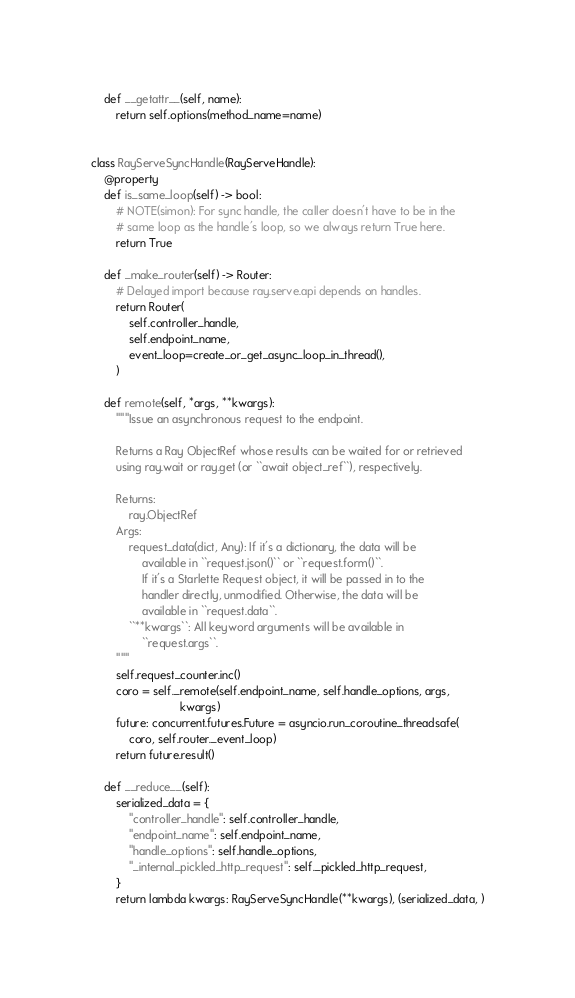<code> <loc_0><loc_0><loc_500><loc_500><_Python_>
    def __getattr__(self, name):
        return self.options(method_name=name)


class RayServeSyncHandle(RayServeHandle):
    @property
    def is_same_loop(self) -> bool:
        # NOTE(simon): For sync handle, the caller doesn't have to be in the
        # same loop as the handle's loop, so we always return True here.
        return True

    def _make_router(self) -> Router:
        # Delayed import because ray.serve.api depends on handles.
        return Router(
            self.controller_handle,
            self.endpoint_name,
            event_loop=create_or_get_async_loop_in_thread(),
        )

    def remote(self, *args, **kwargs):
        """Issue an asynchronous request to the endpoint.

        Returns a Ray ObjectRef whose results can be waited for or retrieved
        using ray.wait or ray.get (or ``await object_ref``), respectively.

        Returns:
            ray.ObjectRef
        Args:
            request_data(dict, Any): If it's a dictionary, the data will be
                available in ``request.json()`` or ``request.form()``.
                If it's a Starlette Request object, it will be passed in to the
                handler directly, unmodified. Otherwise, the data will be
                available in ``request.data``.
            ``**kwargs``: All keyword arguments will be available in
                ``request.args``.
        """
        self.request_counter.inc()
        coro = self._remote(self.endpoint_name, self.handle_options, args,
                            kwargs)
        future: concurrent.futures.Future = asyncio.run_coroutine_threadsafe(
            coro, self.router._event_loop)
        return future.result()

    def __reduce__(self):
        serialized_data = {
            "controller_handle": self.controller_handle,
            "endpoint_name": self.endpoint_name,
            "handle_options": self.handle_options,
            "_internal_pickled_http_request": self._pickled_http_request,
        }
        return lambda kwargs: RayServeSyncHandle(**kwargs), (serialized_data, )
</code> 